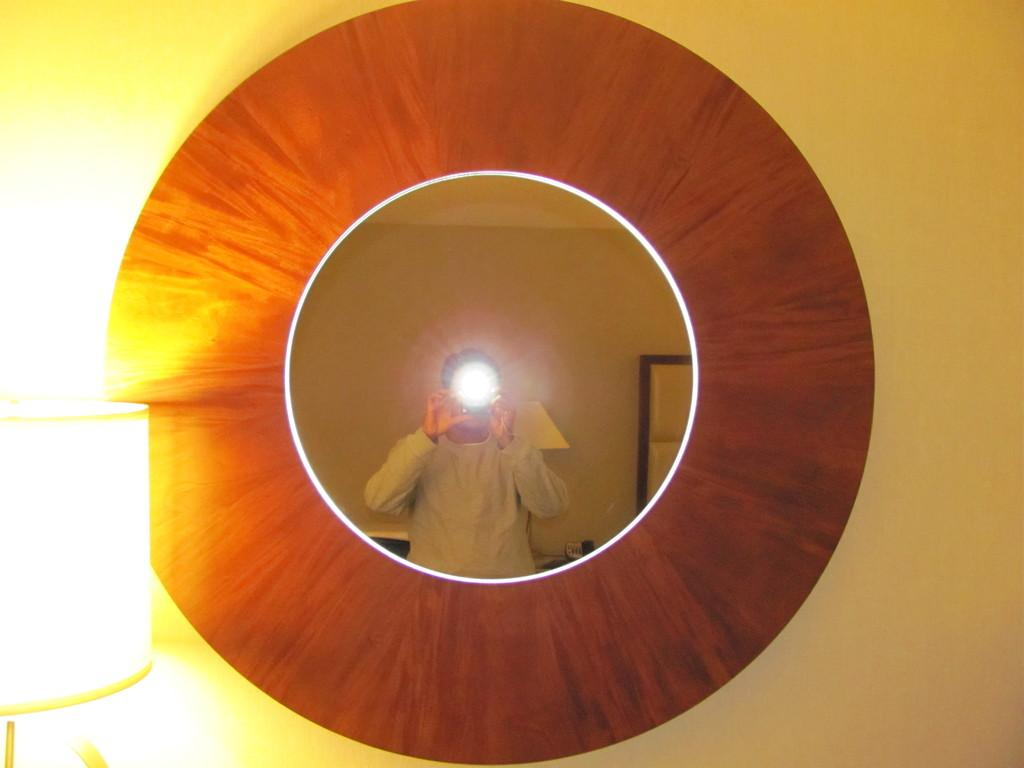What object is located on the left side of the image? There is a light on the left side of the image. What can be seen in the middle of the image? There is a mirror in the middle of the image. What is visible on the mirror? A reflected image of a human is visible on the mirror. What type of drug is being sold on the left side of the image? There is no drug present in the image; it features a light on the left side. Can you see any sea creatures in the mirror? There are no sea creatures visible in the image; it features a reflected image of a human on the mirror. 